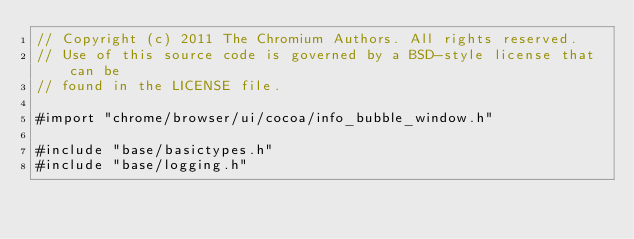Convert code to text. <code><loc_0><loc_0><loc_500><loc_500><_ObjectiveC_>// Copyright (c) 2011 The Chromium Authors. All rights reserved.
// Use of this source code is governed by a BSD-style license that can be
// found in the LICENSE file.

#import "chrome/browser/ui/cocoa/info_bubble_window.h"

#include "base/basictypes.h"
#include "base/logging.h"</code> 